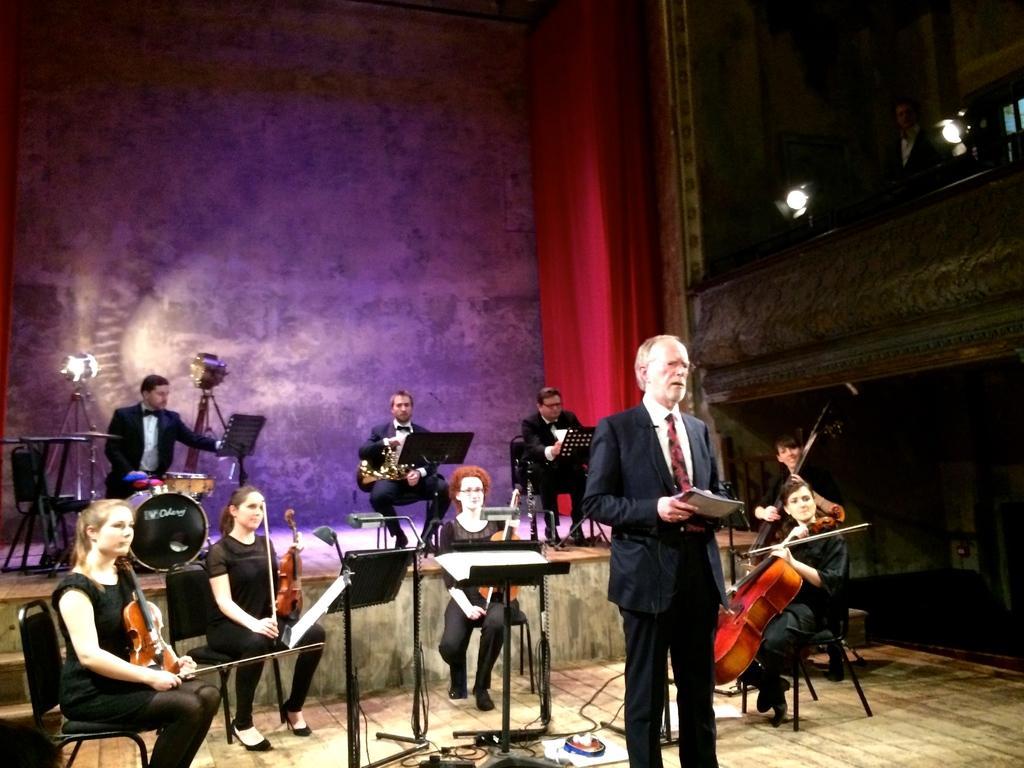Could you give a brief overview of what you see in this image? In this image there are group of persons who are playing musical instruments and at the foreground of the image there is a person standing and holding microphone and book and at the background of the image there is a blue color. 